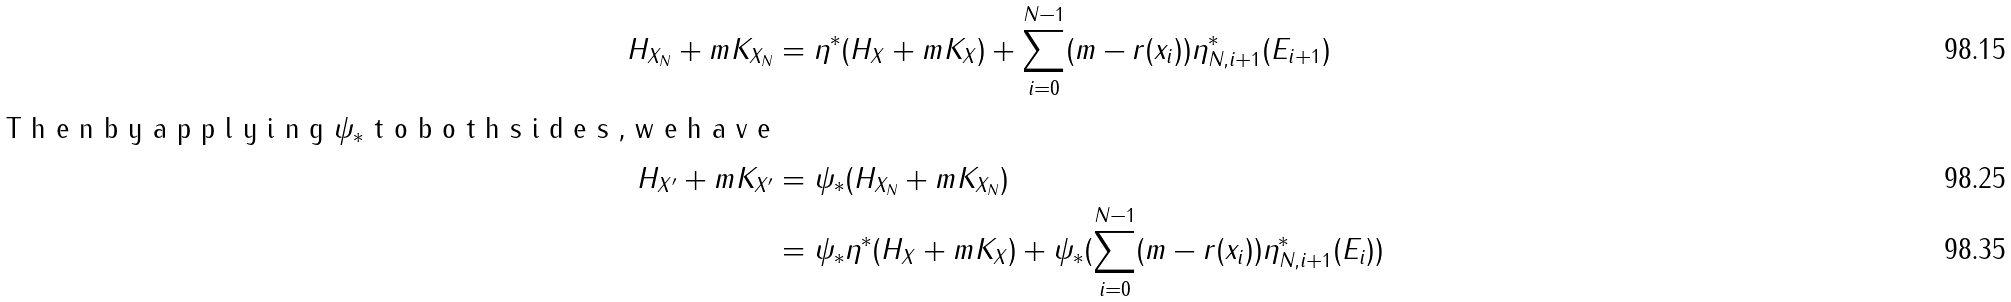Convert formula to latex. <formula><loc_0><loc_0><loc_500><loc_500>H _ { X _ { N } } + m K _ { X _ { N } } & = \eta ^ { \ast } ( H _ { X } + m K _ { X } ) + \sum _ { i = 0 } ^ { N - 1 } ( m - r ( x _ { i } ) ) \eta ^ { \ast } _ { N , i + 1 } ( E _ { i + 1 } ) \\ \intertext { T h e n b y a p p l y i n g $ { \psi _ { \ast } } $ t o b o t h s i d e s , w e h a v e } H _ { X ^ { \prime } } + m K _ { X ^ { \prime } } & = \psi _ { \ast } ( H _ { X _ { N } } + m K _ { X _ { N } } ) \\ & = \psi _ { \ast } \eta ^ { \ast } ( H _ { X } + m K _ { X } ) + \psi _ { \ast } ( \sum _ { i = 0 } ^ { N - 1 } ( m - r ( x _ { i } ) ) \eta ^ { \ast } _ { N , i + 1 } ( E _ { i } ) )</formula> 